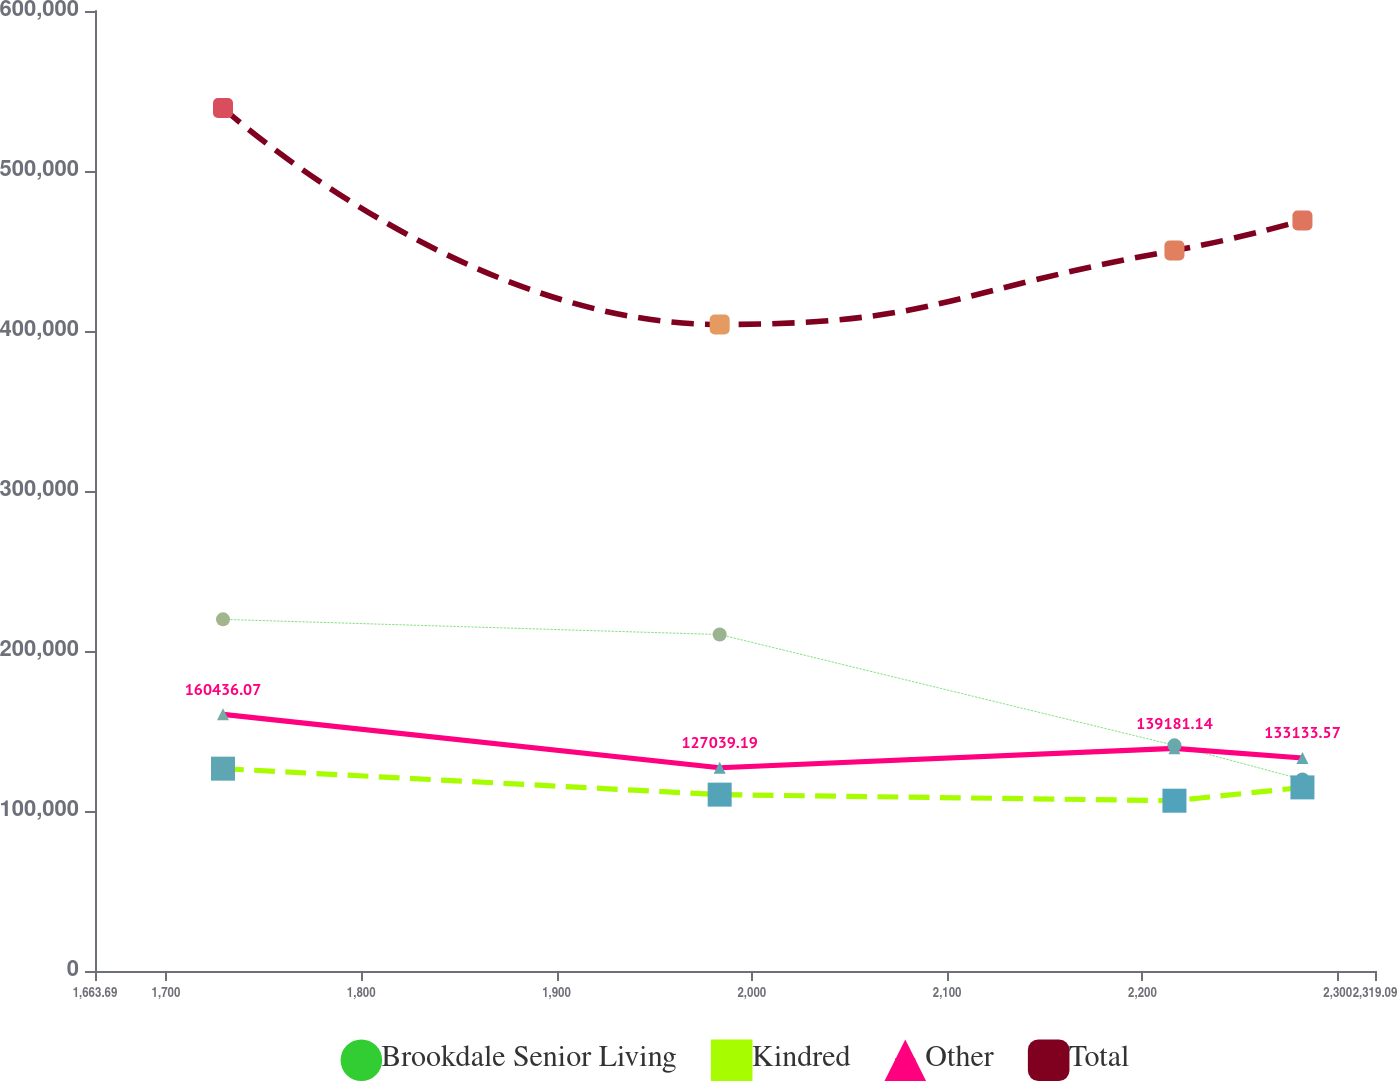<chart> <loc_0><loc_0><loc_500><loc_500><line_chart><ecel><fcel>Brookdale Senior Living<fcel>Kindred<fcel>Other<fcel>Total<nl><fcel>1729.23<fcel>219775<fcel>126472<fcel>160436<fcel>539350<nl><fcel>1983.54<fcel>210299<fcel>110234<fcel>127039<fcel>404076<nl><fcel>2216.4<fcel>141042<fcel>106440<fcel>139181<fcel>450338<nl><fcel>2281.94<fcel>119698<fcel>114752<fcel>133134<fcel>469108<nl><fcel>2384.63<fcel>131566<fcel>112238<fcel>156264<fcel>351657<nl></chart> 